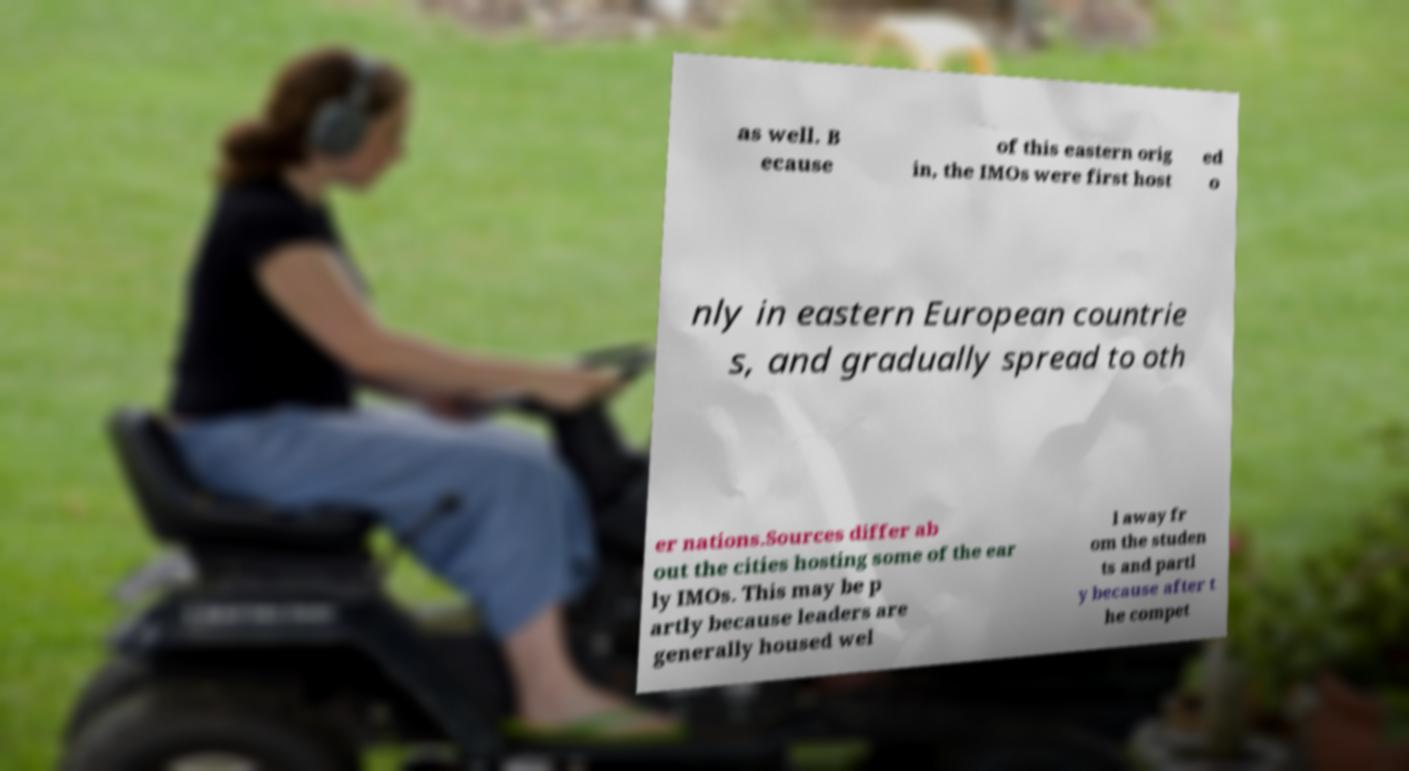Please identify and transcribe the text found in this image. as well. B ecause of this eastern orig in, the IMOs were first host ed o nly in eastern European countrie s, and gradually spread to oth er nations.Sources differ ab out the cities hosting some of the ear ly IMOs. This may be p artly because leaders are generally housed wel l away fr om the studen ts and partl y because after t he compet 